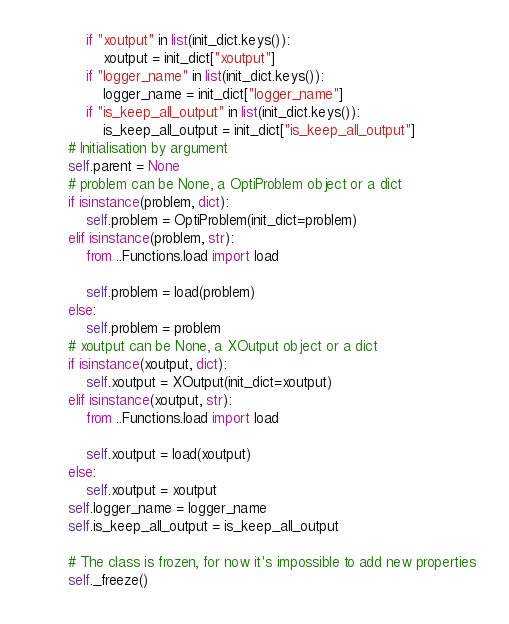<code> <loc_0><loc_0><loc_500><loc_500><_Python_>            if "xoutput" in list(init_dict.keys()):
                xoutput = init_dict["xoutput"]
            if "logger_name" in list(init_dict.keys()):
                logger_name = init_dict["logger_name"]
            if "is_keep_all_output" in list(init_dict.keys()):
                is_keep_all_output = init_dict["is_keep_all_output"]
        # Initialisation by argument
        self.parent = None
        # problem can be None, a OptiProblem object or a dict
        if isinstance(problem, dict):
            self.problem = OptiProblem(init_dict=problem)
        elif isinstance(problem, str):
            from ..Functions.load import load

            self.problem = load(problem)
        else:
            self.problem = problem
        # xoutput can be None, a XOutput object or a dict
        if isinstance(xoutput, dict):
            self.xoutput = XOutput(init_dict=xoutput)
        elif isinstance(xoutput, str):
            from ..Functions.load import load

            self.xoutput = load(xoutput)
        else:
            self.xoutput = xoutput
        self.logger_name = logger_name
        self.is_keep_all_output = is_keep_all_output

        # The class is frozen, for now it's impossible to add new properties
        self._freeze()
</code> 